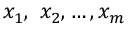<formula> <loc_0><loc_0><loc_500><loc_500>x _ { 1 } , \ x _ { 2 } , \dots , x _ { m }</formula> 